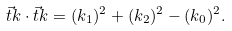<formula> <loc_0><loc_0><loc_500><loc_500>\vec { t } { k } \cdot \vec { t } { k } = ( k _ { 1 } ) ^ { 2 } + ( k _ { 2 } ) ^ { 2 } - ( k _ { 0 } ) ^ { 2 } .</formula> 